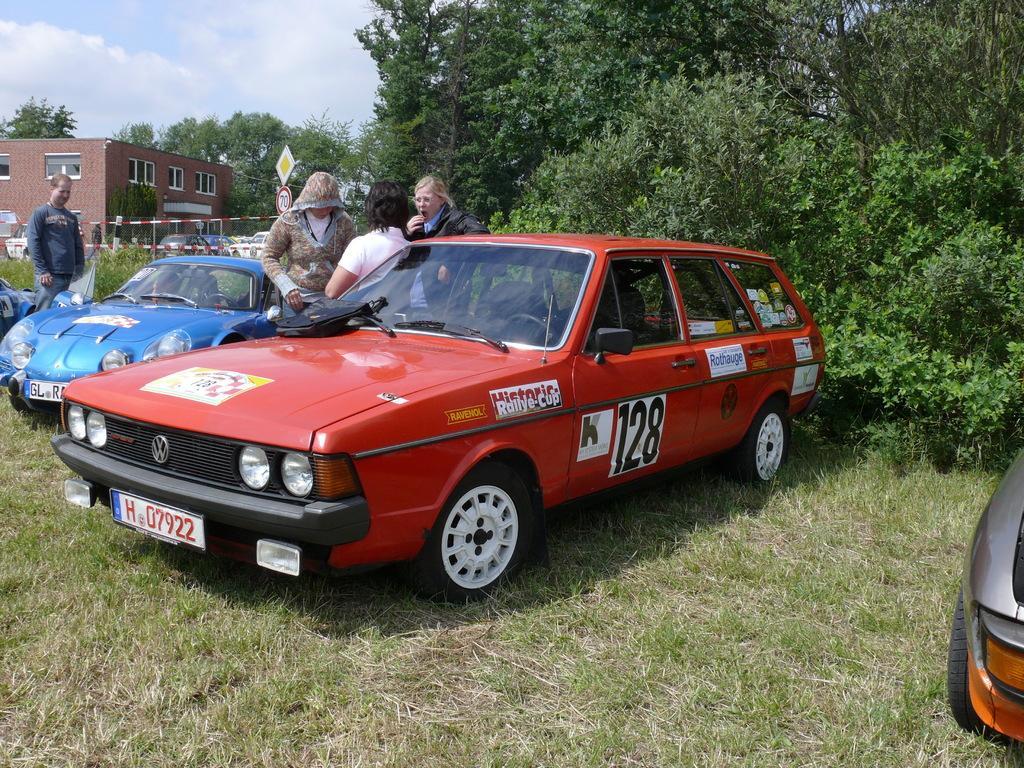Describe this image in one or two sentences. In this picture there is a group of person were standing near to the blue car and red car. On the left there is a man who is wearing jacket and trouser. He is standing near to the plants. In the background I can see many cars which are parked in front of the building. On the right I can see many trees. In the top left corner I can see the sky and clouds. 